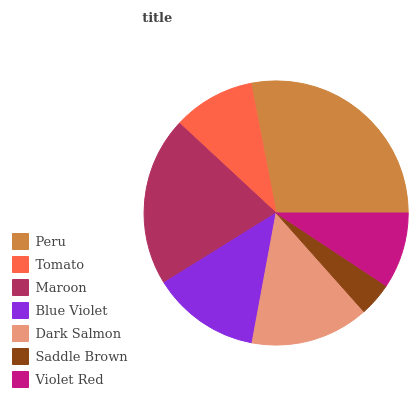Is Saddle Brown the minimum?
Answer yes or no. Yes. Is Peru the maximum?
Answer yes or no. Yes. Is Tomato the minimum?
Answer yes or no. No. Is Tomato the maximum?
Answer yes or no. No. Is Peru greater than Tomato?
Answer yes or no. Yes. Is Tomato less than Peru?
Answer yes or no. Yes. Is Tomato greater than Peru?
Answer yes or no. No. Is Peru less than Tomato?
Answer yes or no. No. Is Blue Violet the high median?
Answer yes or no. Yes. Is Blue Violet the low median?
Answer yes or no. Yes. Is Saddle Brown the high median?
Answer yes or no. No. Is Tomato the low median?
Answer yes or no. No. 